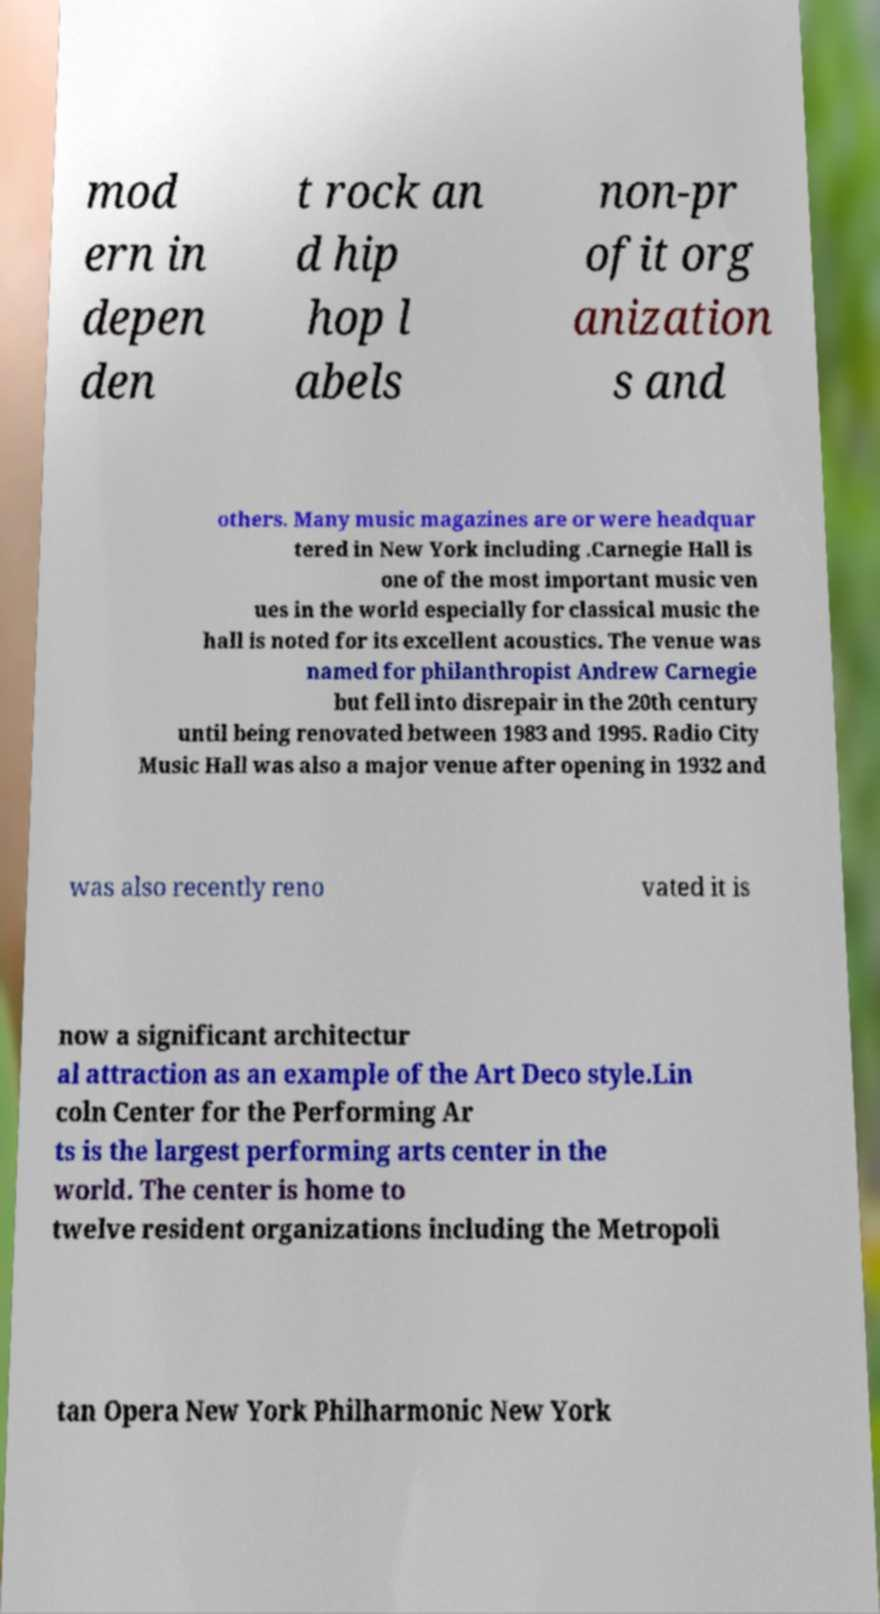I need the written content from this picture converted into text. Can you do that? mod ern in depen den t rock an d hip hop l abels non-pr ofit org anization s and others. Many music magazines are or were headquar tered in New York including .Carnegie Hall is one of the most important music ven ues in the world especially for classical music the hall is noted for its excellent acoustics. The venue was named for philanthropist Andrew Carnegie but fell into disrepair in the 20th century until being renovated between 1983 and 1995. Radio City Music Hall was also a major venue after opening in 1932 and was also recently reno vated it is now a significant architectur al attraction as an example of the Art Deco style.Lin coln Center for the Performing Ar ts is the largest performing arts center in the world. The center is home to twelve resident organizations including the Metropoli tan Opera New York Philharmonic New York 